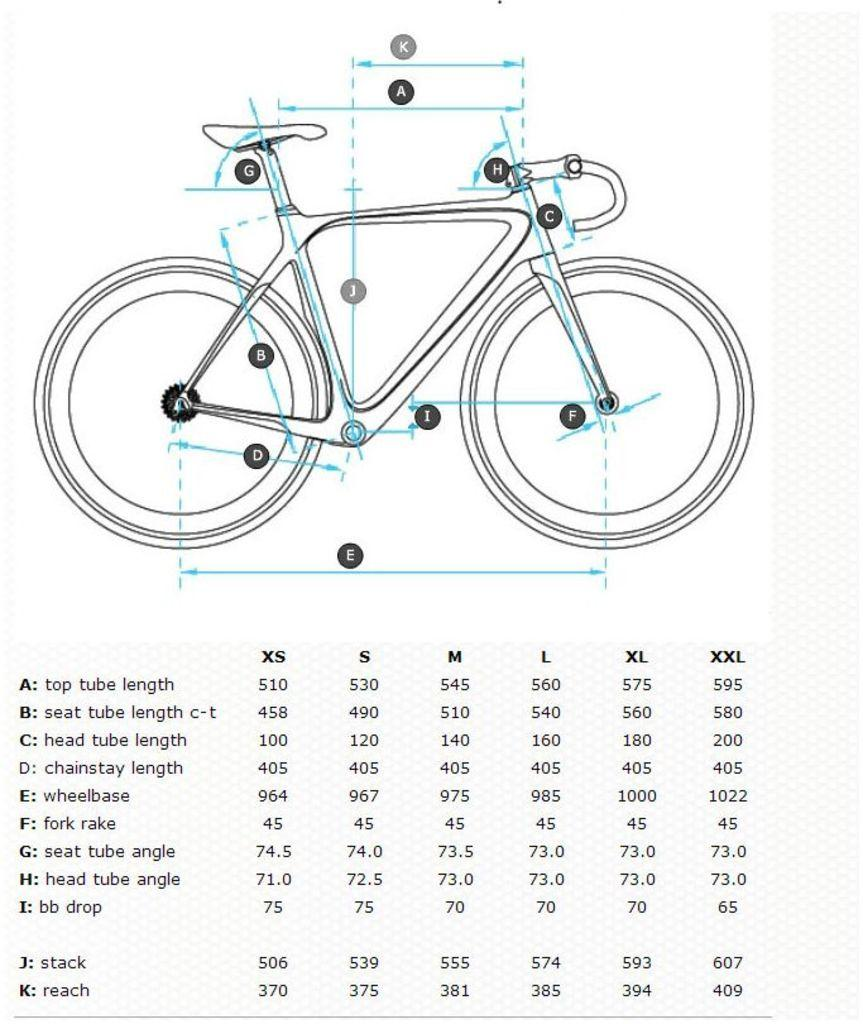<image>
Provide a brief description of the given image. A diagram of a bike is above a legend listing the components of the bike with top tube length being the first listed length. 